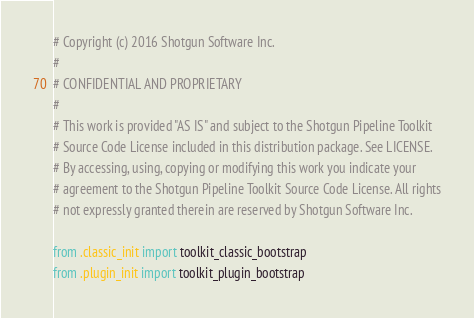Convert code to text. <code><loc_0><loc_0><loc_500><loc_500><_Python_># Copyright (c) 2016 Shotgun Software Inc.
#
# CONFIDENTIAL AND PROPRIETARY
#
# This work is provided "AS IS" and subject to the Shotgun Pipeline Toolkit
# Source Code License included in this distribution package. See LICENSE.
# By accessing, using, copying or modifying this work you indicate your
# agreement to the Shotgun Pipeline Toolkit Source Code License. All rights
# not expressly granted therein are reserved by Shotgun Software Inc.

from .classic_init import toolkit_classic_bootstrap
from .plugin_init import toolkit_plugin_bootstrap
</code> 